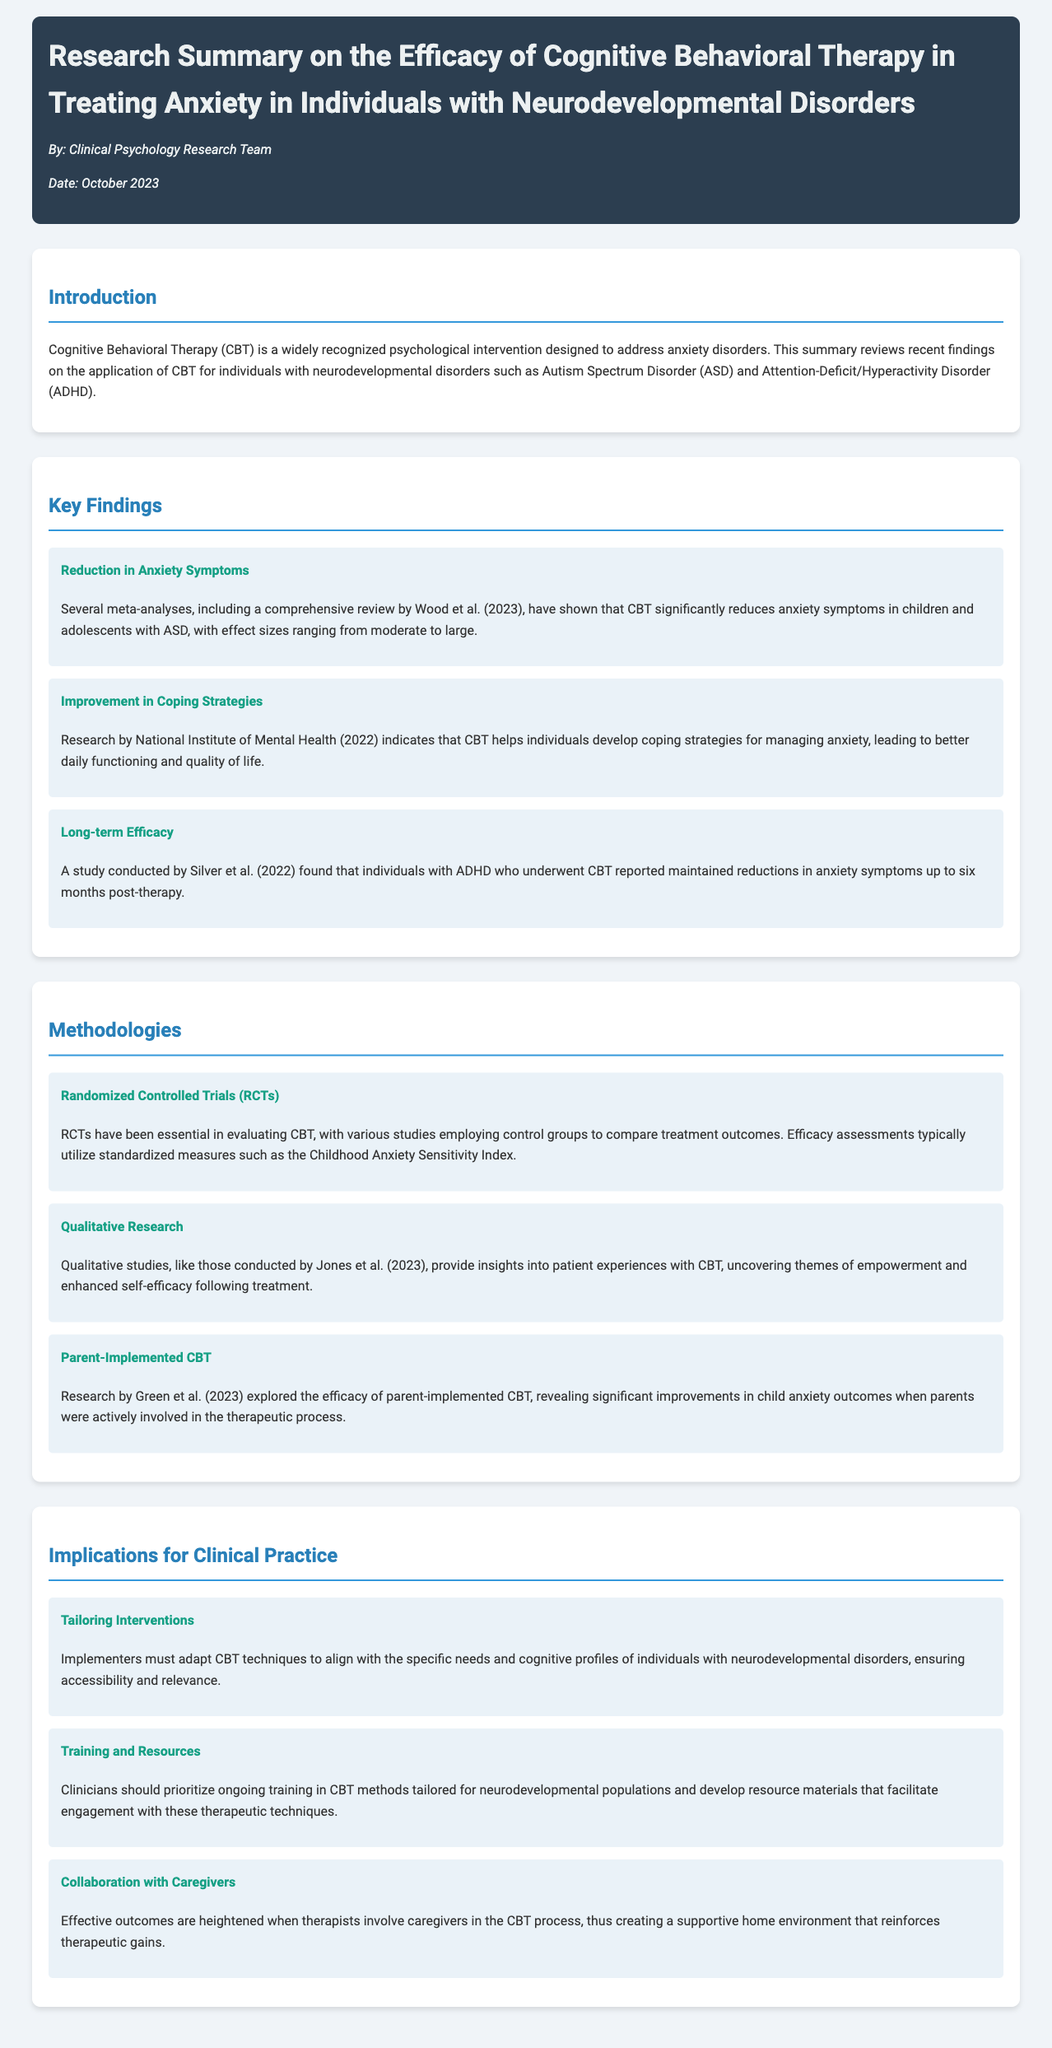What is the title of the document? The title is found in the header section of the document.
Answer: Research Summary on the Efficacy of Cognitive Behavioral Therapy in Treating Anxiety in Individuals with Neurodevelopmental Disorders Who conducted a comprehensive review in 2023? Wood et al. conducted a review referenced in the findings.
Answer: Wood et al Which methodology is essential for evaluating CBT? This methodology is mentioned in the section on Methodologies.
Answer: Randomized Controlled Trials (RCTs) What are some outcomes improved by CBT according to the National Institute of Mental Health? The specific outcomes improved are detailed in the findings section.
Answer: Coping strategies How long did individuals with ADHD maintain reductions in anxiety symptoms post-therapy? The duration is specified in the findings about long-term efficacy.
Answer: Six months What does CBT help individuals develop? This is mentioned in the Key Findings of the document.
Answer: Coping strategies What should clinicians prioritize according to the implications for clinical practice? The implication advises what clinicians should do regarding their training.
Answer: Ongoing training in CBT methods Who should be involved in the CBT process for better outcomes? This involves a group mentioned in the implications.
Answer: Caregivers 